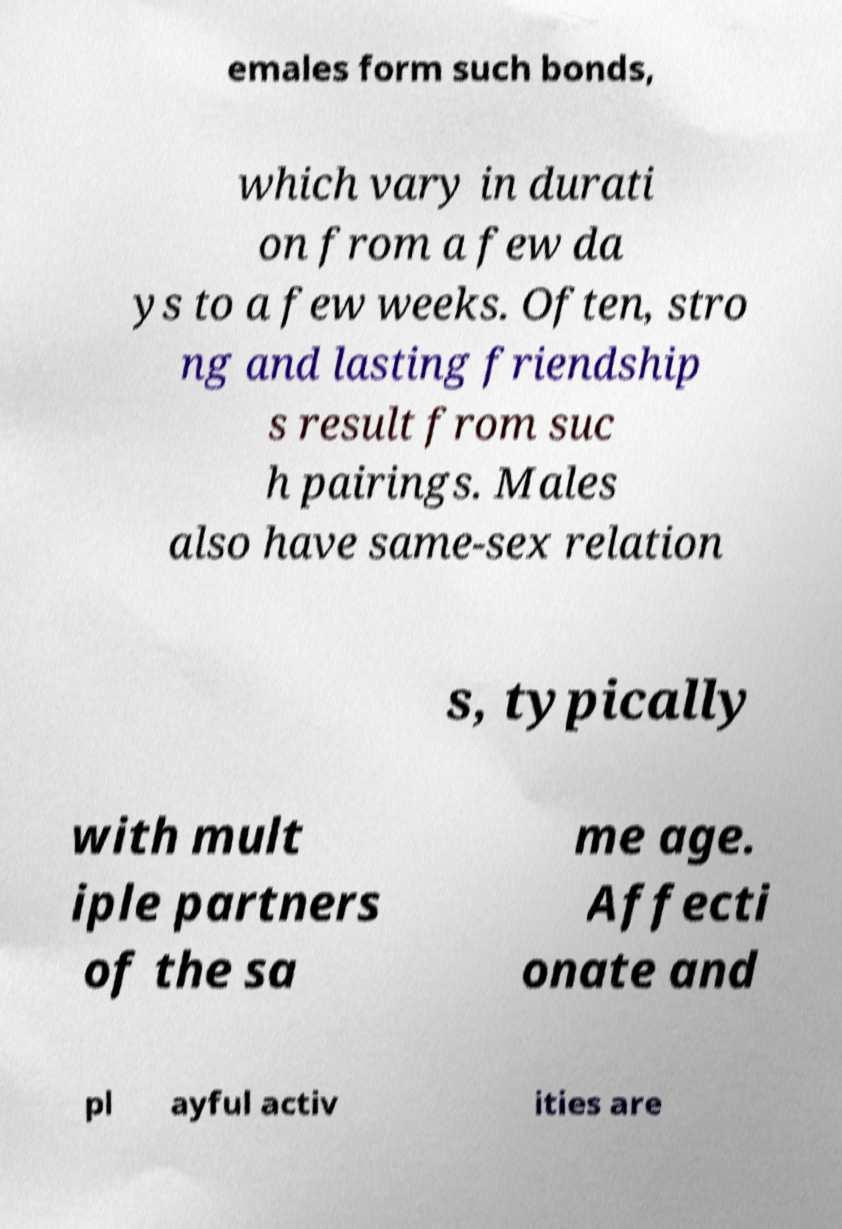Can you accurately transcribe the text from the provided image for me? emales form such bonds, which vary in durati on from a few da ys to a few weeks. Often, stro ng and lasting friendship s result from suc h pairings. Males also have same-sex relation s, typically with mult iple partners of the sa me age. Affecti onate and pl ayful activ ities are 